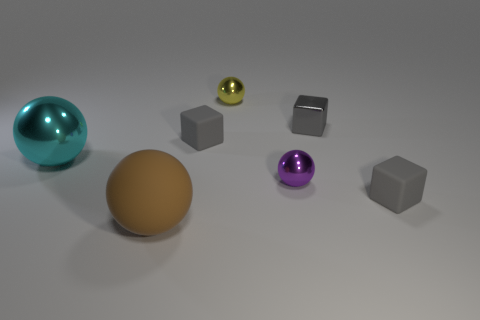What kind of material do the objects look like they are made of? The spheres give off reflections and highlights that suggest they are made of a glossy material, possibly metal or polished stone. The cubes look more matte, suggesting a possible plastic or rubber composition, with the exception of one cube that has a reflective metallic surface. If you were to interpret the image artistically, what theme or message might it convey? Artistically, the image may evoke themes of diversity and individuality, with each object standing out in its own color and shape. It could also be seen as a representation of harmony among different elements, symbolizing coexistence despite differences. 